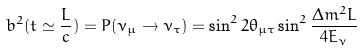<formula> <loc_0><loc_0><loc_500><loc_500>b ^ { 2 } ( t \simeq \frac { L } { c } ) = P ( \nu _ { \mu } \rightarrow \nu _ { \tau } ) = \sin ^ { 2 } 2 \theta _ { \mu \tau } \sin ^ { 2 } \frac { \Delta m ^ { 2 } L } { 4 E _ { \nu } }</formula> 